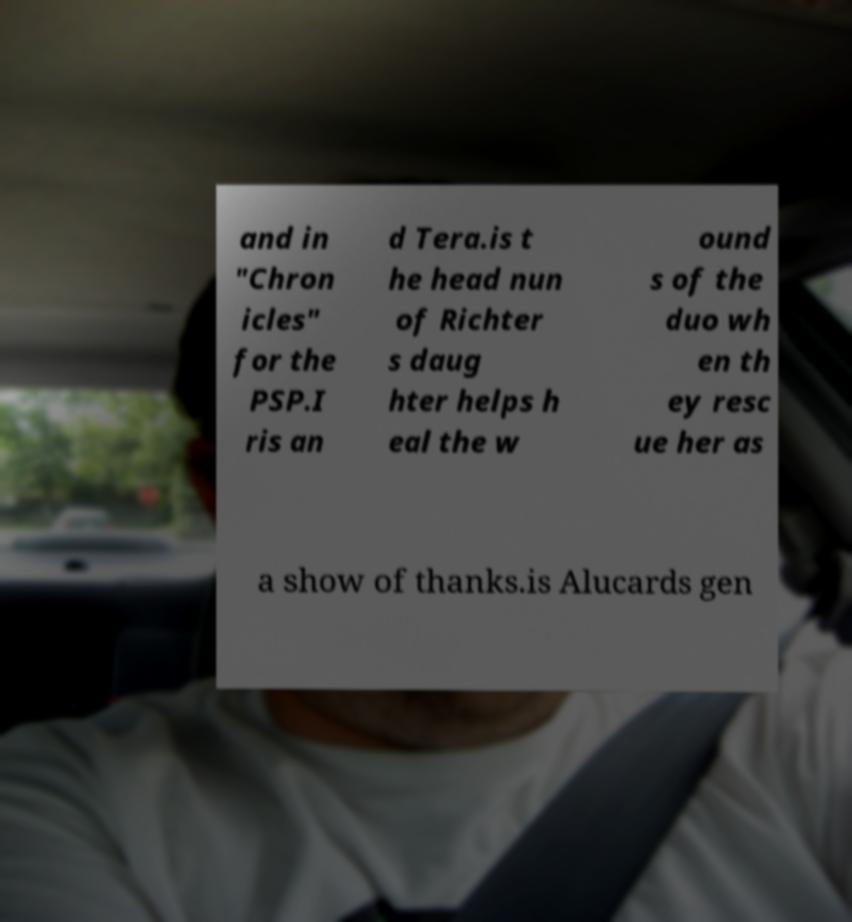What messages or text are displayed in this image? I need them in a readable, typed format. and in "Chron icles" for the PSP.I ris an d Tera.is t he head nun of Richter s daug hter helps h eal the w ound s of the duo wh en th ey resc ue her as a show of thanks.is Alucards gen 